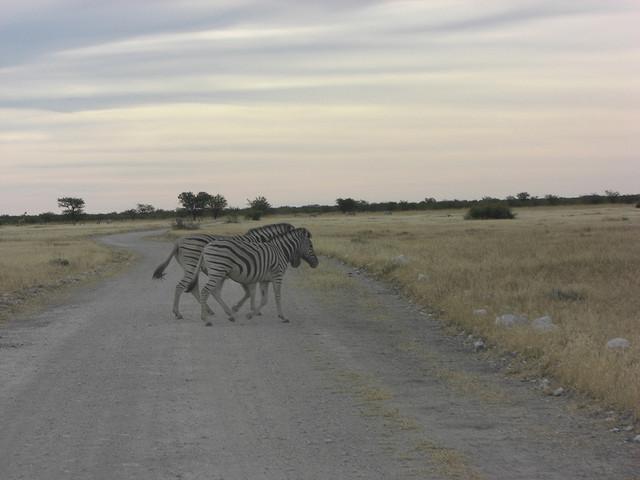How many animals are crossing the road?
Short answer required. 2. How many types of animals are in the picture?
Keep it brief. 1. Are the animals real?
Short answer required. Yes. Do you see mountains?
Keep it brief. No. How many zebras are there?
Quick response, please. 2. Are they domesticated animals?
Write a very short answer. No. Are there rocks along the edge of the road?
Keep it brief. Yes. 